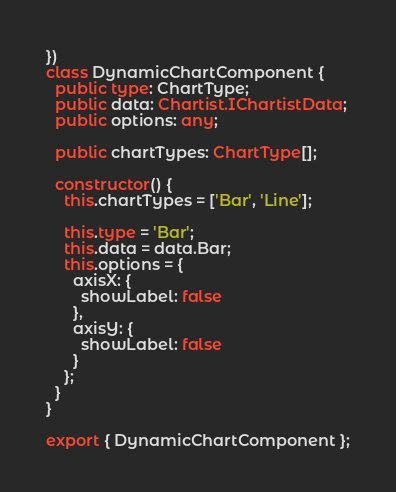Convert code to text. <code><loc_0><loc_0><loc_500><loc_500><_TypeScript_>})
class DynamicChartComponent {
  public type: ChartType;
  public data: Chartist.IChartistData;
  public options: any;

  public chartTypes: ChartType[];

  constructor() {
    this.chartTypes = ['Bar', 'Line'];

    this.type = 'Bar';
    this.data = data.Bar;
    this.options = {
      axisX: {
        showLabel: false
      },
      axisY: {
        showLabel: false
      }
    };
  }
}

export { DynamicChartComponent };
</code> 